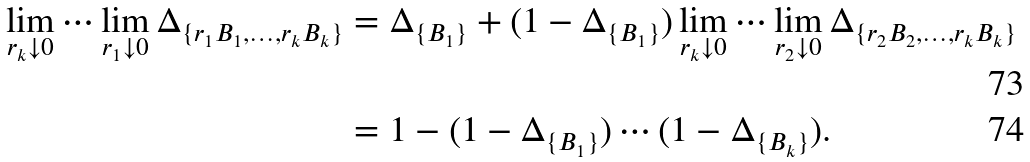<formula> <loc_0><loc_0><loc_500><loc_500>\lim _ { r _ { k } \downarrow 0 } \cdots \lim _ { r _ { 1 } \downarrow 0 } \Delta _ { \{ r _ { 1 } B _ { 1 } , \dots , r _ { k } B _ { k } \} } & = \Delta _ { \{ B _ { 1 } \} } + ( 1 - \Delta _ { \{ B _ { 1 } \} } ) \lim _ { r _ { k } \downarrow 0 } \cdots \lim _ { r _ { 2 } \downarrow 0 } \Delta _ { \{ r _ { 2 } B _ { 2 } , \dots , r _ { k } B _ { k } \} } \\ & = 1 - ( 1 - \Delta _ { \{ B _ { 1 } \} } ) \cdots ( 1 - \Delta _ { \{ B _ { k } \} } ) .</formula> 